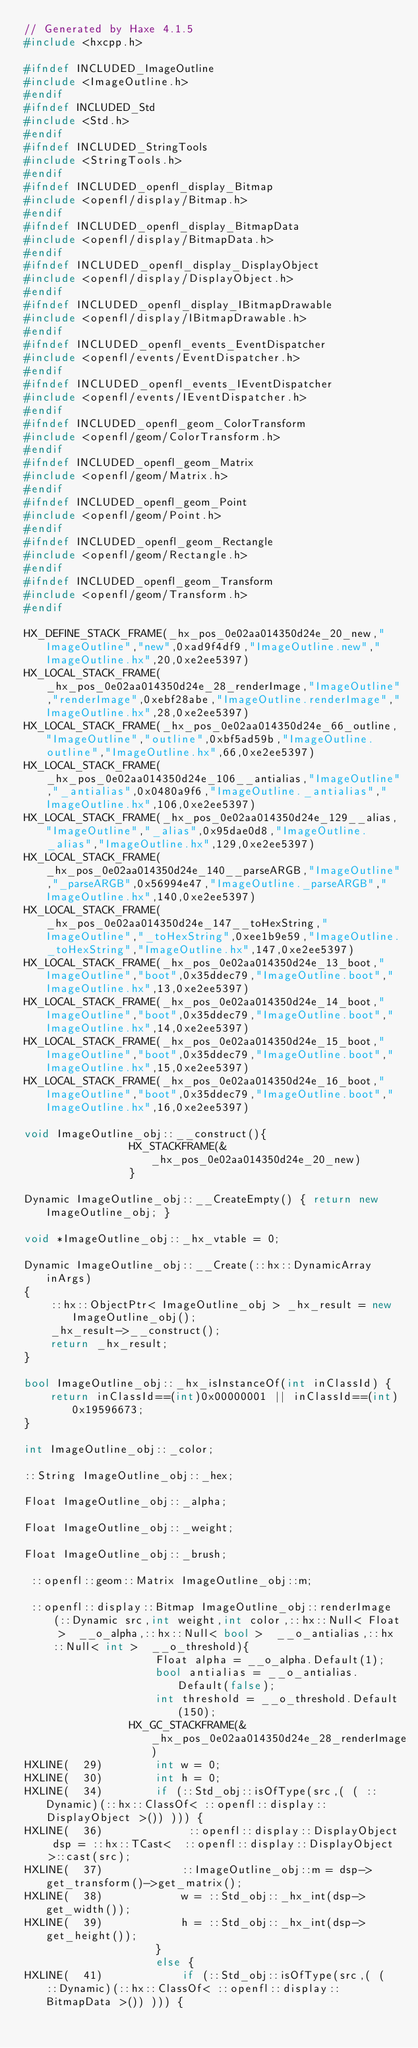<code> <loc_0><loc_0><loc_500><loc_500><_C++_>// Generated by Haxe 4.1.5
#include <hxcpp.h>

#ifndef INCLUDED_ImageOutline
#include <ImageOutline.h>
#endif
#ifndef INCLUDED_Std
#include <Std.h>
#endif
#ifndef INCLUDED_StringTools
#include <StringTools.h>
#endif
#ifndef INCLUDED_openfl_display_Bitmap
#include <openfl/display/Bitmap.h>
#endif
#ifndef INCLUDED_openfl_display_BitmapData
#include <openfl/display/BitmapData.h>
#endif
#ifndef INCLUDED_openfl_display_DisplayObject
#include <openfl/display/DisplayObject.h>
#endif
#ifndef INCLUDED_openfl_display_IBitmapDrawable
#include <openfl/display/IBitmapDrawable.h>
#endif
#ifndef INCLUDED_openfl_events_EventDispatcher
#include <openfl/events/EventDispatcher.h>
#endif
#ifndef INCLUDED_openfl_events_IEventDispatcher
#include <openfl/events/IEventDispatcher.h>
#endif
#ifndef INCLUDED_openfl_geom_ColorTransform
#include <openfl/geom/ColorTransform.h>
#endif
#ifndef INCLUDED_openfl_geom_Matrix
#include <openfl/geom/Matrix.h>
#endif
#ifndef INCLUDED_openfl_geom_Point
#include <openfl/geom/Point.h>
#endif
#ifndef INCLUDED_openfl_geom_Rectangle
#include <openfl/geom/Rectangle.h>
#endif
#ifndef INCLUDED_openfl_geom_Transform
#include <openfl/geom/Transform.h>
#endif

HX_DEFINE_STACK_FRAME(_hx_pos_0e02aa014350d24e_20_new,"ImageOutline","new",0xad9f4df9,"ImageOutline.new","ImageOutline.hx",20,0xe2ee5397)
HX_LOCAL_STACK_FRAME(_hx_pos_0e02aa014350d24e_28_renderImage,"ImageOutline","renderImage",0xebf28abe,"ImageOutline.renderImage","ImageOutline.hx",28,0xe2ee5397)
HX_LOCAL_STACK_FRAME(_hx_pos_0e02aa014350d24e_66_outline,"ImageOutline","outline",0xbf5ad59b,"ImageOutline.outline","ImageOutline.hx",66,0xe2ee5397)
HX_LOCAL_STACK_FRAME(_hx_pos_0e02aa014350d24e_106__antialias,"ImageOutline","_antialias",0x0480a9f6,"ImageOutline._antialias","ImageOutline.hx",106,0xe2ee5397)
HX_LOCAL_STACK_FRAME(_hx_pos_0e02aa014350d24e_129__alias,"ImageOutline","_alias",0x95dae0d8,"ImageOutline._alias","ImageOutline.hx",129,0xe2ee5397)
HX_LOCAL_STACK_FRAME(_hx_pos_0e02aa014350d24e_140__parseARGB,"ImageOutline","_parseARGB",0x56994e47,"ImageOutline._parseARGB","ImageOutline.hx",140,0xe2ee5397)
HX_LOCAL_STACK_FRAME(_hx_pos_0e02aa014350d24e_147__toHexString,"ImageOutline","_toHexString",0xee1b9e59,"ImageOutline._toHexString","ImageOutline.hx",147,0xe2ee5397)
HX_LOCAL_STACK_FRAME(_hx_pos_0e02aa014350d24e_13_boot,"ImageOutline","boot",0x35ddec79,"ImageOutline.boot","ImageOutline.hx",13,0xe2ee5397)
HX_LOCAL_STACK_FRAME(_hx_pos_0e02aa014350d24e_14_boot,"ImageOutline","boot",0x35ddec79,"ImageOutline.boot","ImageOutline.hx",14,0xe2ee5397)
HX_LOCAL_STACK_FRAME(_hx_pos_0e02aa014350d24e_15_boot,"ImageOutline","boot",0x35ddec79,"ImageOutline.boot","ImageOutline.hx",15,0xe2ee5397)
HX_LOCAL_STACK_FRAME(_hx_pos_0e02aa014350d24e_16_boot,"ImageOutline","boot",0x35ddec79,"ImageOutline.boot","ImageOutline.hx",16,0xe2ee5397)

void ImageOutline_obj::__construct(){
            	HX_STACKFRAME(&_hx_pos_0e02aa014350d24e_20_new)
            	}

Dynamic ImageOutline_obj::__CreateEmpty() { return new ImageOutline_obj; }

void *ImageOutline_obj::_hx_vtable = 0;

Dynamic ImageOutline_obj::__Create(::hx::DynamicArray inArgs)
{
	::hx::ObjectPtr< ImageOutline_obj > _hx_result = new ImageOutline_obj();
	_hx_result->__construct();
	return _hx_result;
}

bool ImageOutline_obj::_hx_isInstanceOf(int inClassId) {
	return inClassId==(int)0x00000001 || inClassId==(int)0x19596673;
}

int ImageOutline_obj::_color;

::String ImageOutline_obj::_hex;

Float ImageOutline_obj::_alpha;

Float ImageOutline_obj::_weight;

Float ImageOutline_obj::_brush;

 ::openfl::geom::Matrix ImageOutline_obj::m;

 ::openfl::display::Bitmap ImageOutline_obj::renderImage(::Dynamic src,int weight,int color,::hx::Null< Float >  __o_alpha,::hx::Null< bool >  __o_antialias,::hx::Null< int >  __o_threshold){
            		Float alpha = __o_alpha.Default(1);
            		bool antialias = __o_antialias.Default(false);
            		int threshold = __o_threshold.Default(150);
            	HX_GC_STACKFRAME(&_hx_pos_0e02aa014350d24e_28_renderImage)
HXLINE(  29)		int w = 0;
HXLINE(  30)		int h = 0;
HXLINE(  34)		if (::Std_obj::isOfType(src,( ( ::Dynamic)(::hx::ClassOf< ::openfl::display::DisplayObject >()) ))) {
HXLINE(  36)			 ::openfl::display::DisplayObject dsp = ::hx::TCast<  ::openfl::display::DisplayObject >::cast(src);
HXLINE(  37)			::ImageOutline_obj::m = dsp->get_transform()->get_matrix();
HXLINE(  38)			w = ::Std_obj::_hx_int(dsp->get_width());
HXLINE(  39)			h = ::Std_obj::_hx_int(dsp->get_height());
            		}
            		else {
HXLINE(  41)			if (::Std_obj::isOfType(src,( ( ::Dynamic)(::hx::ClassOf< ::openfl::display::BitmapData >()) ))) {</code> 